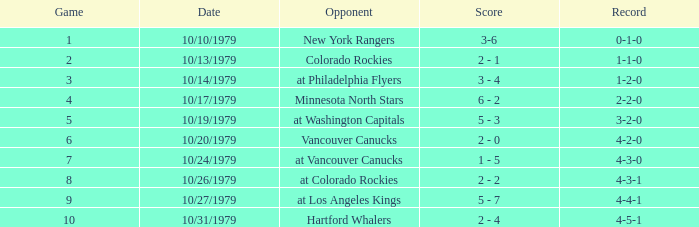What is the score for the rival vancouver canucks? 2 - 0. 